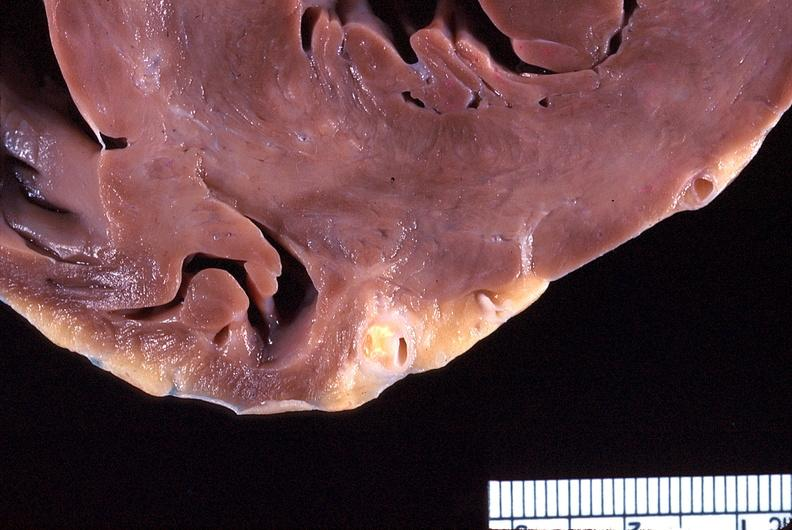does this image show heart, coronary artery, atherosclerosis?
Answer the question using a single word or phrase. Yes 